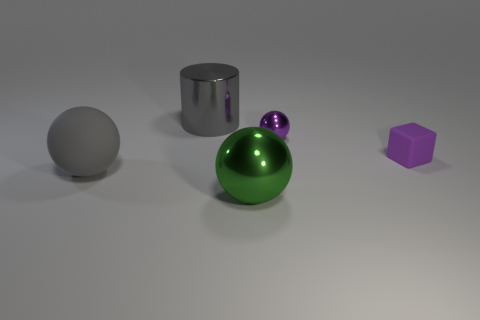Assuming the large green sphere is made of glass, what can we infer about its thickness? Assuming the large green sphere is made of glass, we can infer its thickness to some extent by observing the distortion and magnification of objects seen through it. However, without a reference or further context, precise measurements cannot be made. 